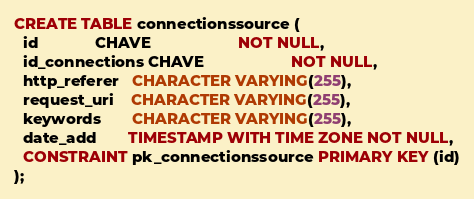<code> <loc_0><loc_0><loc_500><loc_500><_SQL_>CREATE TABLE connectionssource (
  id             CHAVE                    NOT NULL,
  id_connections CHAVE                    NOT NULL,
  http_referer   CHARACTER VARYING(255),
  request_uri    CHARACTER VARYING(255),
  keywords       CHARACTER VARYING(255),
  date_add       TIMESTAMP WITH TIME ZONE NOT NULL,
  CONSTRAINT pk_connectionssource PRIMARY KEY (id)
);</code> 